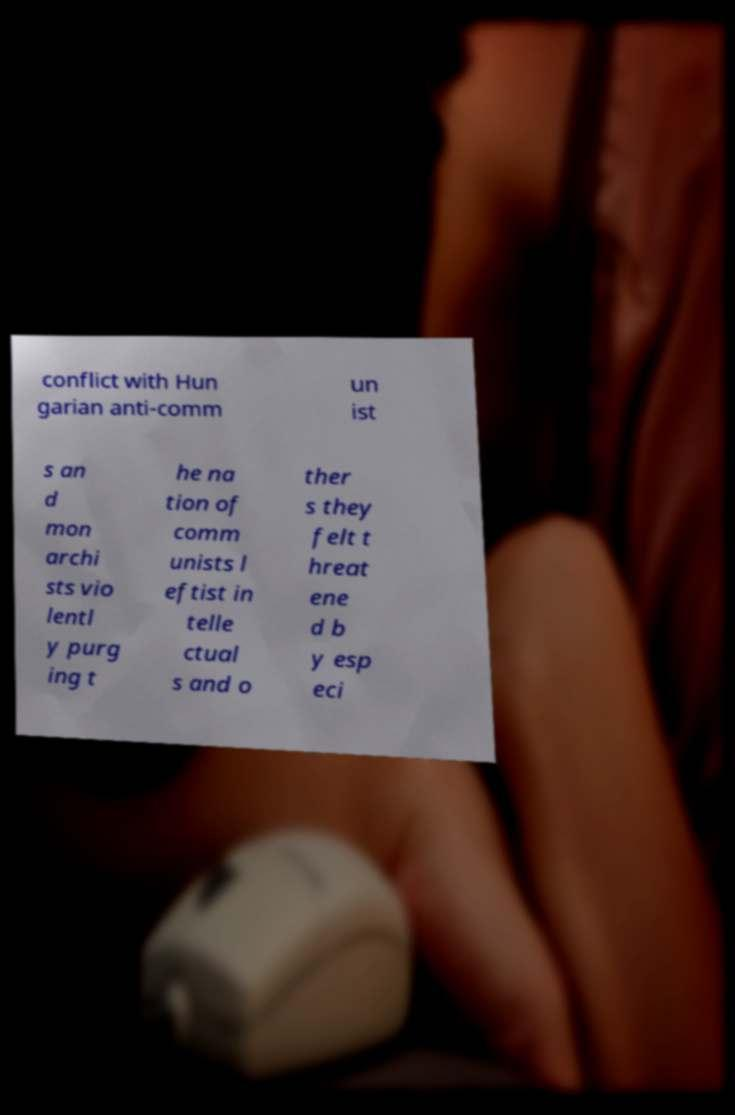Please identify and transcribe the text found in this image. conflict with Hun garian anti-comm un ist s an d mon archi sts vio lentl y purg ing t he na tion of comm unists l eftist in telle ctual s and o ther s they felt t hreat ene d b y esp eci 